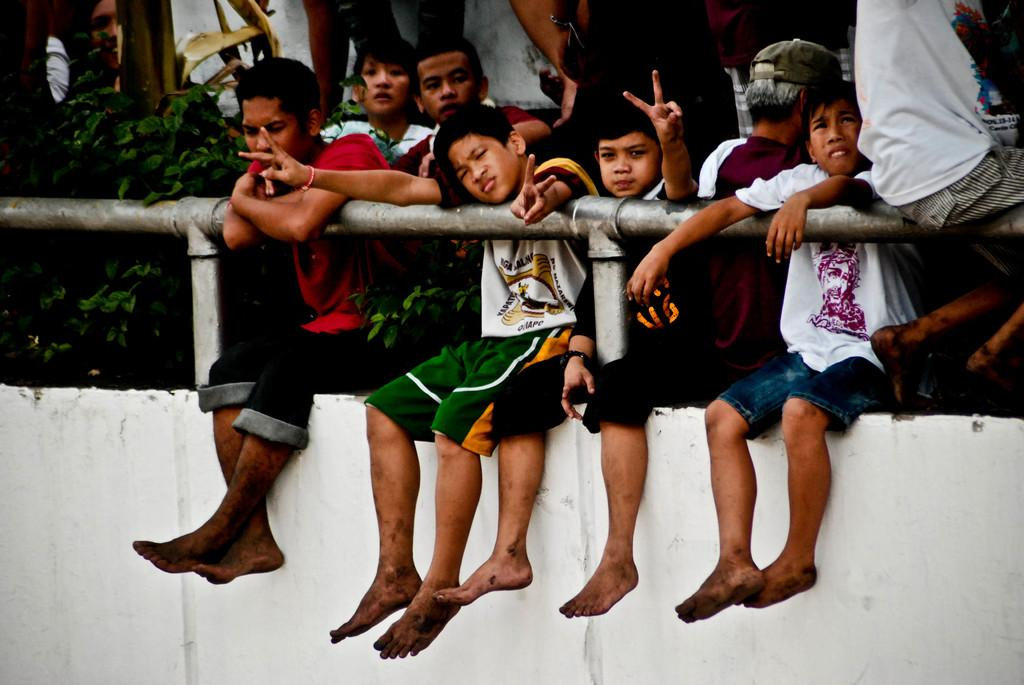What is the color of the wall in the image? The wall in the image is white. What are the children doing on the wall? The children are sitting on the wall. What else can be seen on the wall besides the children? There is a pipe on the wall. Can you describe the background of the image? There are other persons visible in the background of the image. What type of cushion is being used by the children to sit on the wall? There is no cushion present in the image; the children are sitting directly on the wall. 